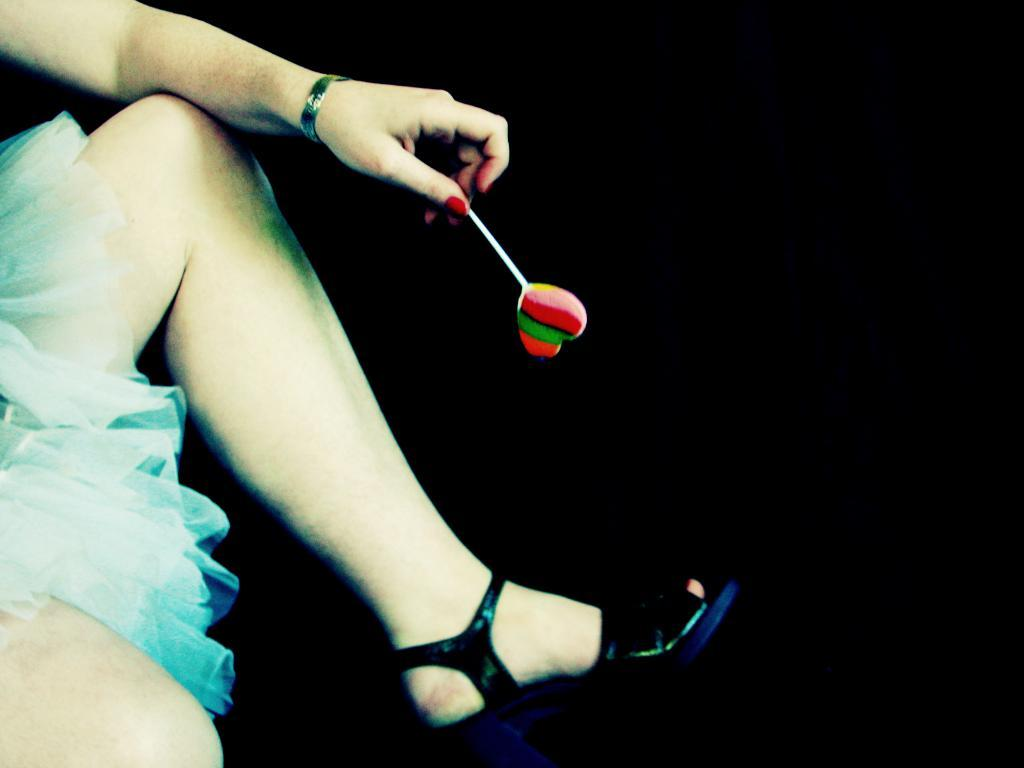Who is present in the image? There is a woman in the image. What is the woman wearing? The woman is wearing a blue dress and black sandals. What is the woman holding in the image? The woman is holding a lollipop. What is the color of the background in the image? The background of the image is black in color. What type of hook can be seen in the woman's hair in the image? There is no hook present in the woman's hair in the image. Can you describe the worm that is crawling on the woman's shoulder in the image? There is no worm present on the woman's shoulder in the image. 